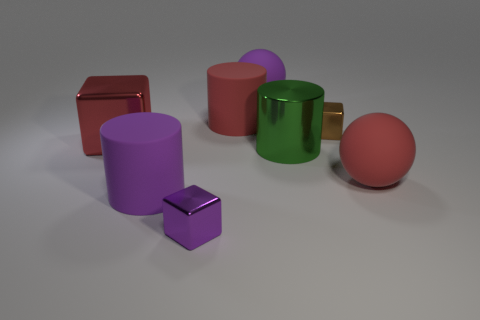Which objects in the image look like they could hold water? The green mug with the golden handle appears to be the only object in the image capable of holding water, thanks to its concave shape and open top. What's the lighting situation like? Where is the light coming from? The shadows in the image suggest a single light source above the scene, slightly towards the front. The light casts soft shadows behind and to the right of the objects, with highlights visible on the upper surfaces and edges closest to the light source. 